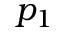Convert formula to latex. <formula><loc_0><loc_0><loc_500><loc_500>p _ { 1 }</formula> 